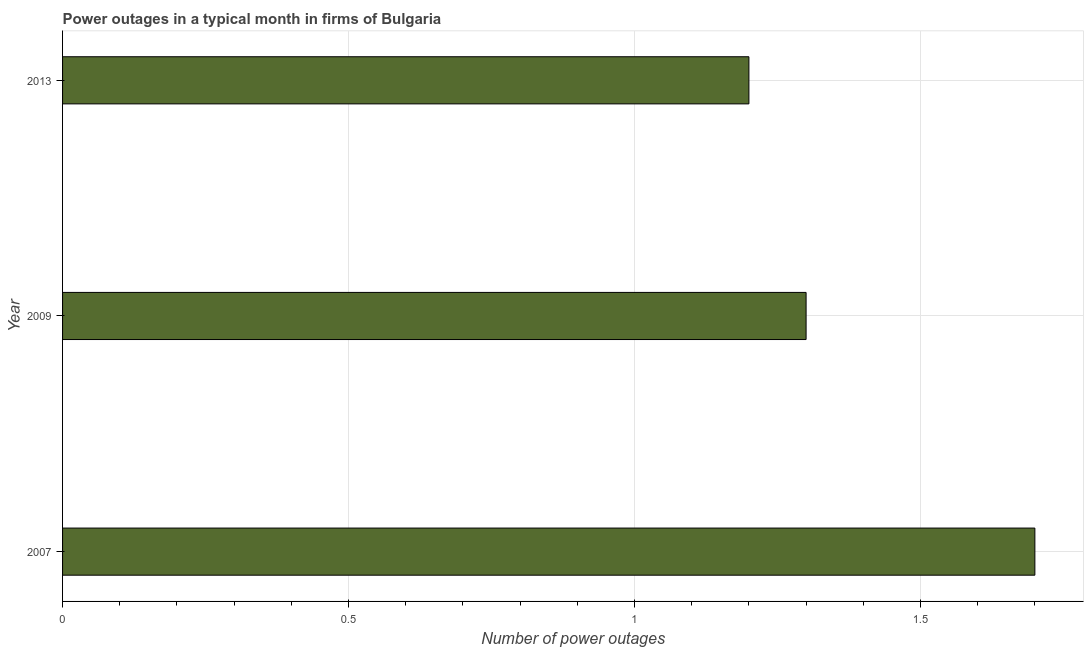What is the title of the graph?
Your answer should be very brief. Power outages in a typical month in firms of Bulgaria. What is the label or title of the X-axis?
Make the answer very short. Number of power outages. Across all years, what is the minimum number of power outages?
Your answer should be very brief. 1.2. What is the difference between the number of power outages in 2007 and 2013?
Make the answer very short. 0.5. What is the average number of power outages per year?
Provide a succinct answer. 1.4. In how many years, is the number of power outages greater than 0.5 ?
Give a very brief answer. 3. What is the ratio of the number of power outages in 2009 to that in 2013?
Offer a terse response. 1.08. Is the number of power outages in 2007 less than that in 2013?
Your answer should be compact. No. Is the sum of the number of power outages in 2007 and 2009 greater than the maximum number of power outages across all years?
Your answer should be compact. Yes. Are all the bars in the graph horizontal?
Keep it short and to the point. Yes. How many years are there in the graph?
Give a very brief answer. 3. What is the difference between two consecutive major ticks on the X-axis?
Provide a short and direct response. 0.5. What is the Number of power outages of 2007?
Ensure brevity in your answer.  1.7. What is the Number of power outages in 2013?
Your answer should be very brief. 1.2. What is the difference between the Number of power outages in 2007 and 2013?
Make the answer very short. 0.5. What is the difference between the Number of power outages in 2009 and 2013?
Offer a very short reply. 0.1. What is the ratio of the Number of power outages in 2007 to that in 2009?
Your answer should be compact. 1.31. What is the ratio of the Number of power outages in 2007 to that in 2013?
Provide a succinct answer. 1.42. What is the ratio of the Number of power outages in 2009 to that in 2013?
Make the answer very short. 1.08. 